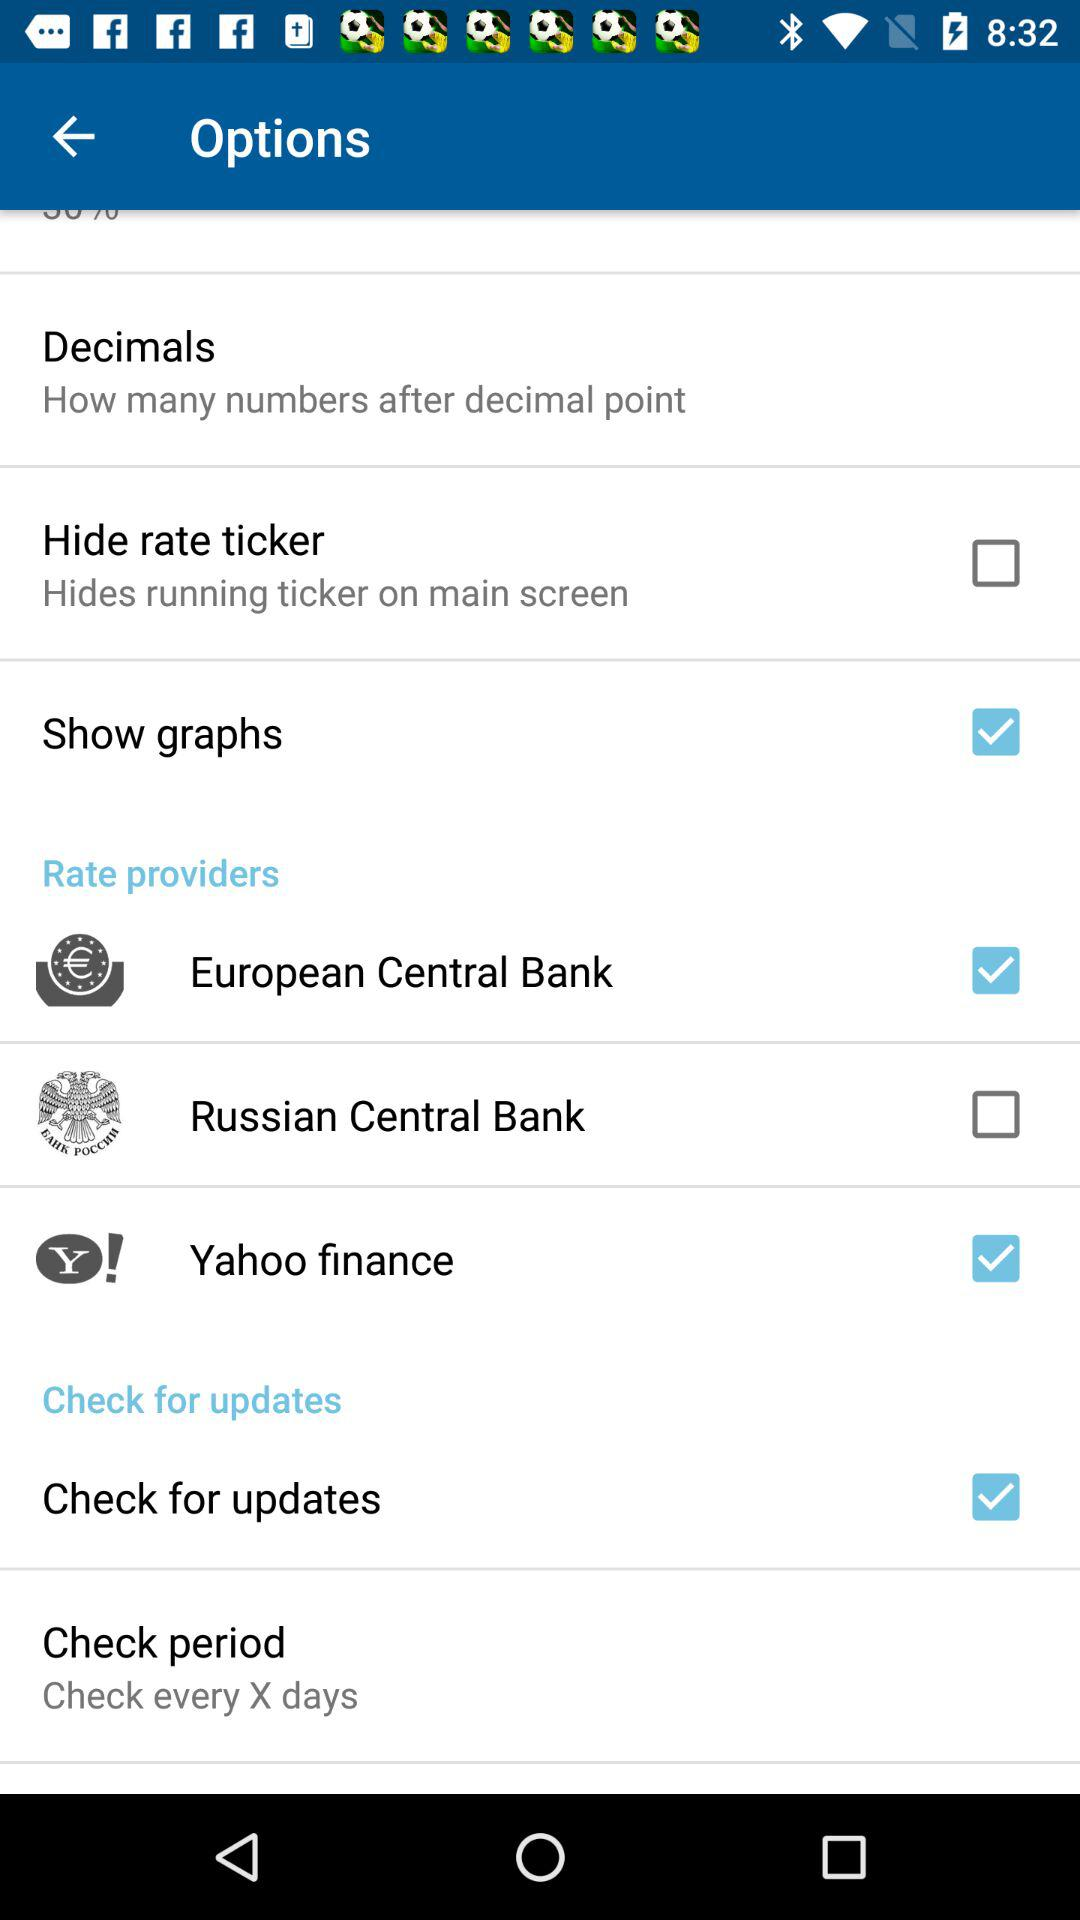How many providers are there to choose from for currency rates?
Answer the question using a single word or phrase. 3 